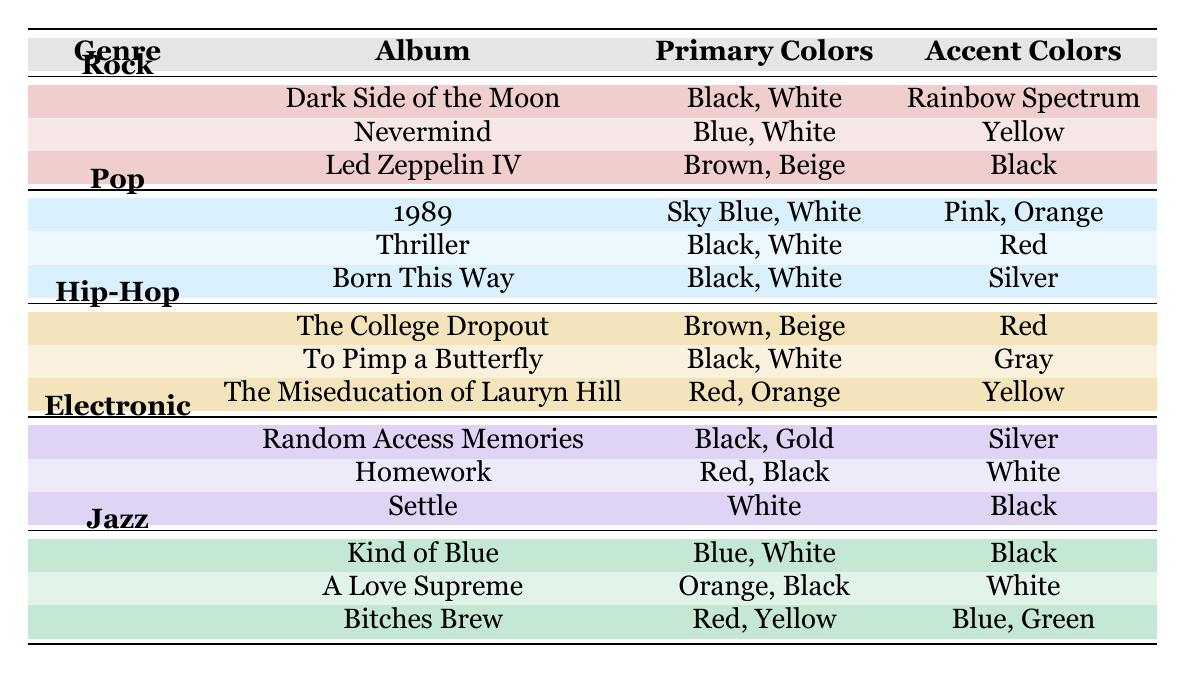What are the primary colors used in "Thriller" by Michael Jackson? The table shows that the primary colors for the album "Thriller" are Black and White.
Answer: Black and White Which genre features the maximum number of different accent colors? By checking the accent colors used across all albums, Pop and Jazz both utilize three colors: Pink, Orange, Red for Pop and Black, White, Blue, Green for Jazz. However, Jazz has four different accent colors as it includes Blue and Green together in its last album, Bitches Brew. Therefore, Jazz features the maximum number of different accent colors.
Answer: Jazz Is "Dark Side of the Moon" the only album listed with a Rainbow Spectrum as an accent color? Looking at the table, the only instance of a Rainbow Spectrum accent color appears under "Dark Side of the Moon," confirming it is indeed the only album with this feature.
Answer: Yes Which genre has the album "The College Dropout"? The table indicates that "The College Dropout" is associated with the Hip-Hop genre.
Answer: Hip-Hop What is the average number of primary colors used across the Electronic genre albums? The Electronic genre has three albums: Random Access Memories with 2 primary colors (Black, Gold), Homework with 2 primary colors (Red, Black), and Settle with 1 primary color (White). The total is 2 + 2 + 1 = 5, and dividing by 3 gives the average: 5/3 = 1.67.
Answer: 1.67 Which albums in the Jazz genre use Black as a primary color? The albums "Kind of Blue" and "A Love Supreme" both use Black as a primary color, as shown in the table.
Answer: Kind of Blue, A Love Supreme Do any Pop albums use Yellow in their color palettes? The table lists the color palettes for Pop albums, and none of them include Yellow among their primary or accent colors.
Answer: No How many albums in total utilize Black as a primary color? Checking across all genres, Black is a primary color for the following albums: "Nevermind" (Rock), "Thriller" (Pop), "To Pimp a Butterfly" (Hip-Hop), "Random Access Memories" (Electronic), "Kind of Blue" (Jazz), and "A Love Supreme" (Jazz), making a total of 6 albums that use Black.
Answer: 6 